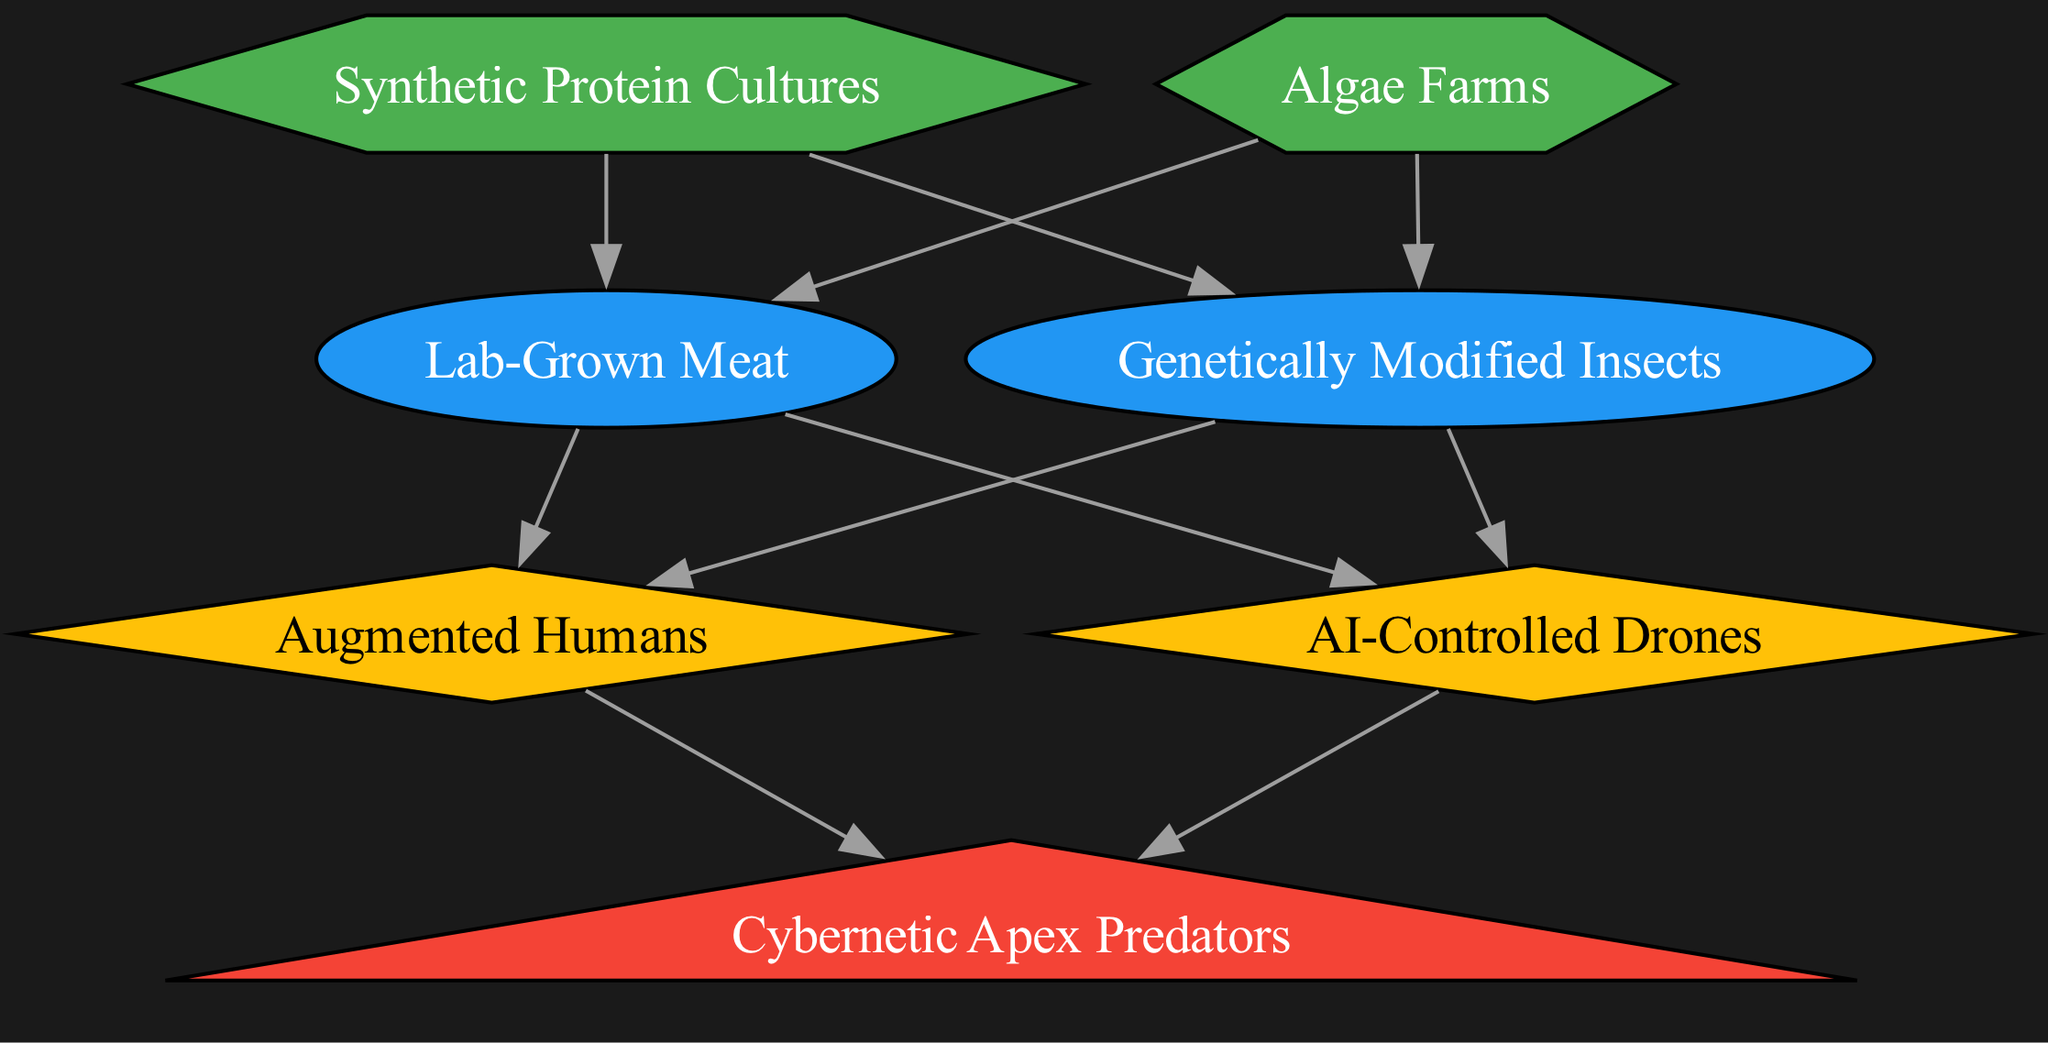What is the total number of nodes in the food chain? To find the total number of nodes, we count each unique element listed in the diagram. There are 7 unique elements identified as Synthetic Protein Cultures, Algae Farms, Lab-Grown Meat, Genetically Modified Insects, Augmented Humans, AI-Controlled Drones, and Cybernetic Apex Predators. Thus, the total count is 7.
Answer: 7 Which element is classified as the Tertiary Consumer? The diagram categorizes Cybernetic Apex Predators as the Tertiary Consumer. It is placed at the top of the food chain, indicating that it preys upon secondary consumers.
Answer: Cybernetic Apex Predators What are the two types of Producers represented in the diagram? The two types of Producers in the diagram are Synthetic Protein Cultures and Algae Farms. Both of these contribute to the initial layer of the food chain by creating energy and nutrients.
Answer: Synthetic Protein Cultures, Algae Farms Which elements are classified as Primary Consumers? The Primary Consumers in the food chain are Lab-Grown Meat and Genetically Modified Insects. These elements directly consume the Producers for energy.
Answer: Lab-Grown Meat, Genetically Modified Insects How many edges are there in the diagram? To find the number of edges, we count the connections (arrows) between the nodes. The data indicates that there are 10 edges connecting various nodes within the food chain.
Answer: 10 Which two elements directly consume Lab-Grown Meat? The elements that directly consume Lab-Grown Meat are Augmented Humans and AI-Controlled Drones, as indicated by the arrows connecting them.
Answer: Augmented Humans, AI-Controlled Drones What is the relationship between Genetically Modified Insects and Cybernetic Apex Predators? The relationship is that Genetically Modified Insects are consumed by Augmented Humans and AI-Controlled Drones, while these secondary consumers are eventually consumed by Cybernetic Apex Predators, forming a connection in the food web.
Answer: Genetically Modified Insects are consumed by Augmented Humans and AI-Controlled Drones, which are then consumed by Cybernetic Apex Predators How many types of consumers are present in the food chain? The food chain contains three types of consumers: Primary Consumers (Lab-Grown Meat, Genetically Modified Insects), Secondary Consumers (Augmented Humans, AI-Controlled Drones), and Tertiary Consumers (Cybernetic Apex Predators). Counting these types yields three distinct categories.
Answer: 3 What is the role of AI-Controlled Drones in the food web? AI-Controlled Drones function as Secondary Consumers in the food web. They obtain energy by consuming both Lab-Grown Meat and Genetically Modified Insects within the cyberpunk ecosystem.
Answer: Secondary Consumer 